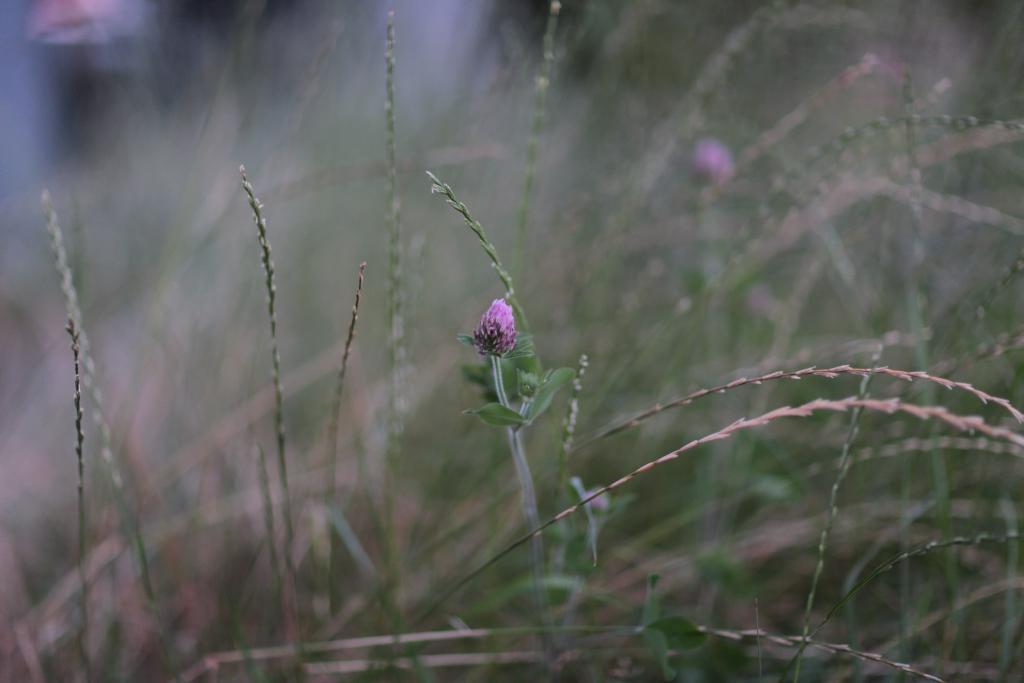How would you summarize this image in a sentence or two? In this picture we can see plants and flower. In the background of the image it is blurry. 